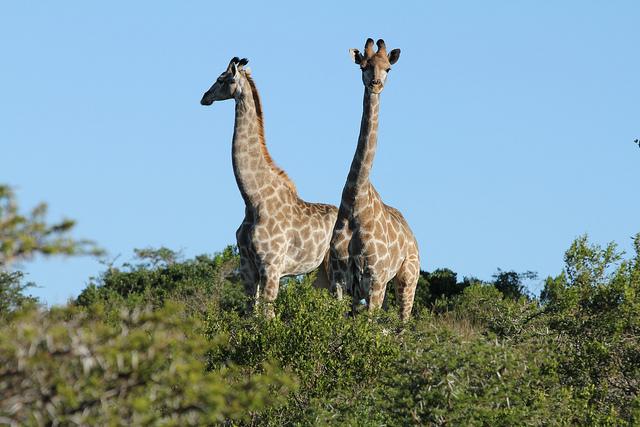How many horns do these animals have?
Concise answer only. 2. How many giraffes are there?
Be succinct. 2. What type of animal is in the image?
Quick response, please. Giraffe. Do these animals have a webbed feet?
Keep it brief. No. What kind of animal's are these?
Write a very short answer. Giraffes. 